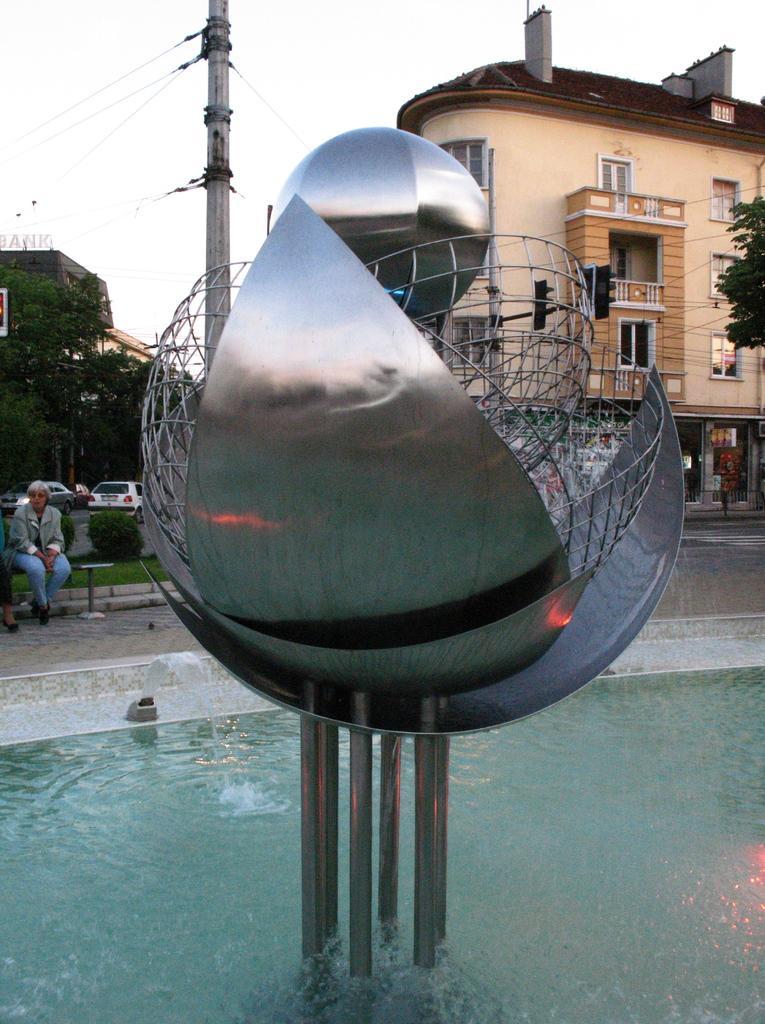Describe this image in one or two sentences. This image consists of a fountain. In the middle, there is an object made up of metal. In the background, there are buildings. And we can see the cars. On the left, there is a person sitting. In the middle, there is a pole. On the right, we can see a tree. 